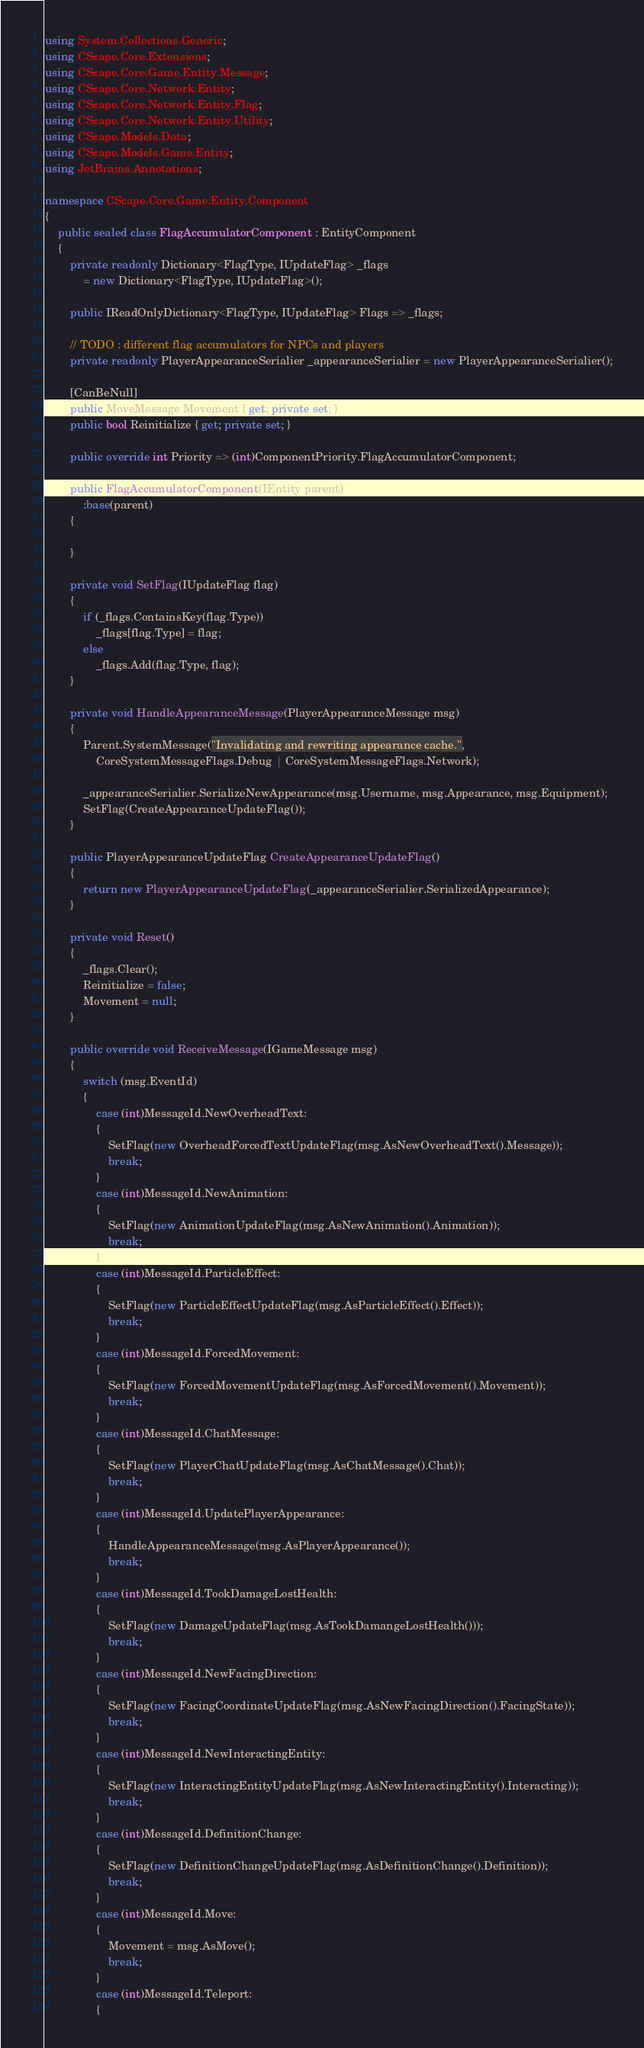<code> <loc_0><loc_0><loc_500><loc_500><_C#_>using System.Collections.Generic;
using CScape.Core.Extensions;
using CScape.Core.Game.Entity.Message;
using CScape.Core.Network.Entity;
using CScape.Core.Network.Entity.Flag;
using CScape.Core.Network.Entity.Utility;
using CScape.Models.Data;
using CScape.Models.Game.Entity;
using JetBrains.Annotations;

namespace CScape.Core.Game.Entity.Component
{
    public sealed class FlagAccumulatorComponent : EntityComponent
    {
        private readonly Dictionary<FlagType, IUpdateFlag> _flags
            = new Dictionary<FlagType, IUpdateFlag>();

        public IReadOnlyDictionary<FlagType, IUpdateFlag> Flags => _flags;

        // TODO : different flag accumulators for NPCs and players
        private readonly PlayerAppearanceSerialier _appearanceSerialier = new PlayerAppearanceSerialier();

        [CanBeNull]
        public MoveMessage Movement { get; private set; }
        public bool Reinitialize { get; private set; }

        public override int Priority => (int)ComponentPriority.FlagAccumulatorComponent;

        public FlagAccumulatorComponent(IEntity parent)
            :base(parent)
        {
        
        }

        private void SetFlag(IUpdateFlag flag)
        {
            if (_flags.ContainsKey(flag.Type))
                _flags[flag.Type] = flag;
            else
                _flags.Add(flag.Type, flag);
        }

        private void HandleAppearanceMessage(PlayerAppearanceMessage msg)
        {
            Parent.SystemMessage("Invalidating and rewriting appearance cache.",
                CoreSystemMessageFlags.Debug | CoreSystemMessageFlags.Network);

            _appearanceSerialier.SerializeNewAppearance(msg.Username, msg.Appearance, msg.Equipment);
            SetFlag(CreateAppearanceUpdateFlag());
        }

        public PlayerAppearanceUpdateFlag CreateAppearanceUpdateFlag()
        {
            return new PlayerAppearanceUpdateFlag(_appearanceSerialier.SerializedAppearance);
        }

        private void Reset()
        {
            _flags.Clear();
            Reinitialize = false;
            Movement = null;
        }

        public override void ReceiveMessage(IGameMessage msg)
        {
            switch (msg.EventId)
            {
                case (int)MessageId.NewOverheadText:
                {
                    SetFlag(new OverheadForcedTextUpdateFlag(msg.AsNewOverheadText().Message));
                    break;
                }
                case (int)MessageId.NewAnimation:
                {
                    SetFlag(new AnimationUpdateFlag(msg.AsNewAnimation().Animation));
                    break;
                }
                case (int)MessageId.ParticleEffect:
                {
                    SetFlag(new ParticleEffectUpdateFlag(msg.AsParticleEffect().Effect));
                    break;
                }
                case (int)MessageId.ForcedMovement:
                {
                    SetFlag(new ForcedMovementUpdateFlag(msg.AsForcedMovement().Movement));
                    break;
                }
                case (int)MessageId.ChatMessage:
                {
                    SetFlag(new PlayerChatUpdateFlag(msg.AsChatMessage().Chat));
                    break;
                }
                case (int)MessageId.UpdatePlayerAppearance:
                {
                    HandleAppearanceMessage(msg.AsPlayerAppearance());
                    break;
                }
                case (int)MessageId.TookDamageLostHealth:
                {
                    SetFlag(new DamageUpdateFlag(msg.AsTookDamangeLostHealth()));
                    break;
                }
                case (int)MessageId.NewFacingDirection:
                {
                    SetFlag(new FacingCoordinateUpdateFlag(msg.AsNewFacingDirection().FacingState));
                    break;
                }
                case (int)MessageId.NewInteractingEntity:
                {
                    SetFlag(new InteractingEntityUpdateFlag(msg.AsNewInteractingEntity().Interacting));
                    break;
                }
                case (int)MessageId.DefinitionChange:
                {
                    SetFlag(new DefinitionChangeUpdateFlag(msg.AsDefinitionChange().Definition));
                    break;
                }
                case (int)MessageId.Move:
                {
                    Movement = msg.AsMove();
                    break;
                }
                case (int)MessageId.Teleport:
                {</code> 